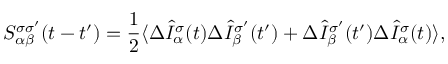<formula> <loc_0><loc_0><loc_500><loc_500>S _ { \alpha \beta } ^ { \sigma \sigma ^ { \prime } } ( t - t ^ { \prime } ) = \frac { 1 } { 2 } \langle \Delta \hat { I } _ { \alpha } ^ { \sigma } ( t ) \Delta \hat { I } _ { \beta } ^ { \sigma ^ { \prime } } ( t ^ { \prime } ) + \Delta \hat { I } _ { \beta } ^ { \sigma ^ { \prime } } ( t ^ { \prime } ) \Delta \hat { I } _ { \alpha } ^ { \sigma } ( t ) \rangle ,</formula> 